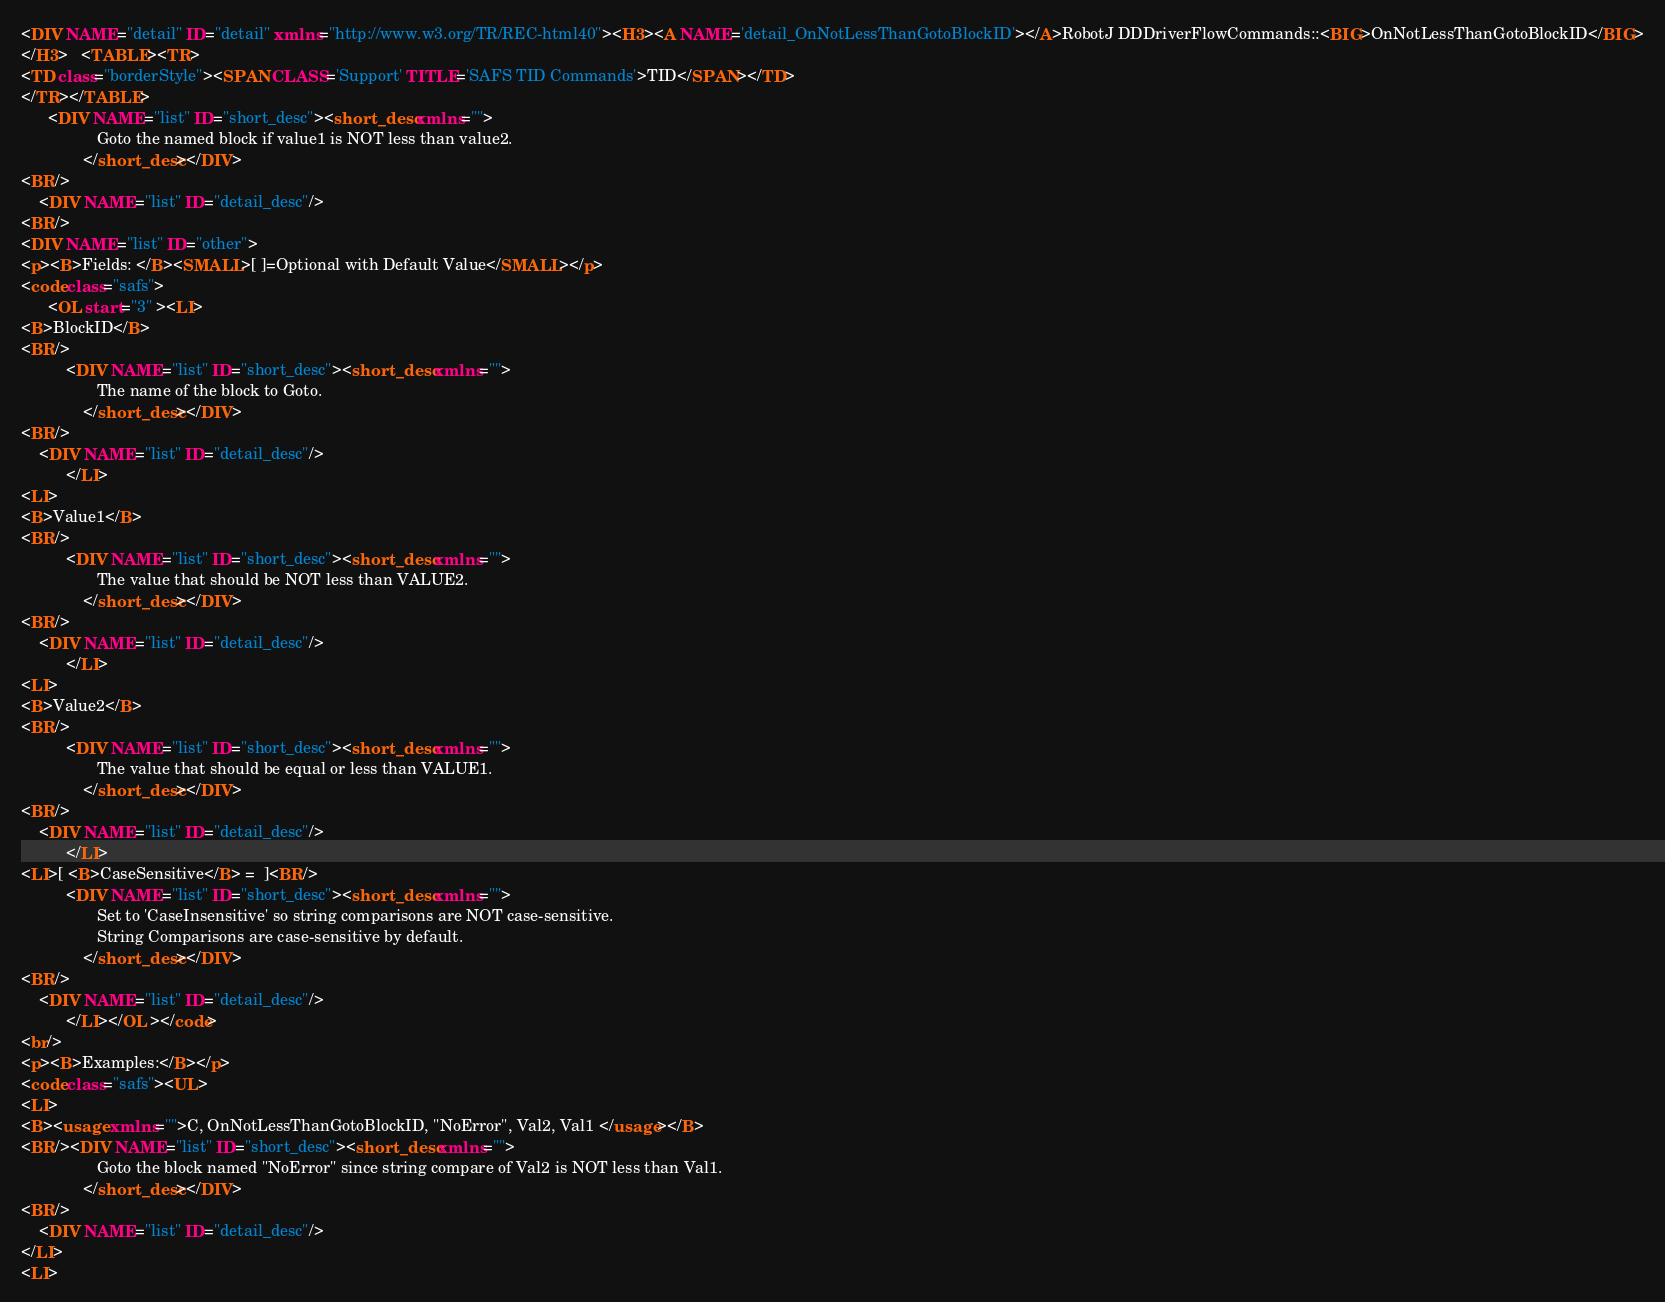<code> <loc_0><loc_0><loc_500><loc_500><_HTML_><DIV NAME="detail" ID="detail" xmlns="http://www.w3.org/TR/REC-html40"><H3><A NAME='detail_OnNotLessThanGotoBlockID'></A>RobotJ DDDriverFlowCommands::<BIG>OnNotLessThanGotoBlockID</BIG>
</H3>   <TABLE><TR>
<TD class="borderStyle"><SPAN CLASS='Support' TITLE='SAFS TID Commands'>TID</SPAN></TD>
</TR></TABLE>
	  <DIV NAME="list" ID="short_desc"><short_desc xmlns=""> 
                 Goto the named block if value1 is NOT less than value2.
              </short_desc></DIV>
<BR/>
	<DIV NAME="list" ID="detail_desc"/>
<BR/>
<DIV NAME="list" ID="other">
<p><B>Fields: </B><SMALL>[ ]=Optional with Default Value</SMALL></p>
<code class="safs">
	  <OL start="3" ><LI>
<B>BlockID</B>
<BR/>
		  <DIV NAME="list" ID="short_desc"><short_desc xmlns=""> 
                 The name of the block to Goto.
              </short_desc></DIV>
<BR/>
	<DIV NAME="list" ID="detail_desc"/>
		  </LI>
<LI>
<B>Value1</B>
<BR/>
		  <DIV NAME="list" ID="short_desc"><short_desc xmlns=""> 
                 The value that should be NOT less than VALUE2.
              </short_desc></DIV>
<BR/>
	<DIV NAME="list" ID="detail_desc"/>
		  </LI>
<LI>
<B>Value2</B>
<BR/>
		  <DIV NAME="list" ID="short_desc"><short_desc xmlns=""> 
                 The value that should be equal or less than VALUE1.
              </short_desc></DIV>
<BR/>
	<DIV NAME="list" ID="detail_desc"/>
		  </LI>
<LI>[ <B>CaseSensitive</B> =  ]<BR/>
		  <DIV NAME="list" ID="short_desc"><short_desc xmlns=""> 
                 Set to 'CaseInsensitive' so string comparisons are NOT case-sensitive.
                 String Comparisons are case-sensitive by default.
              </short_desc></DIV>
<BR/>
	<DIV NAME="list" ID="detail_desc"/>
		  </LI></OL ></code>
<br/>
<p><B>Examples:</B></p>
<code class="safs"><UL>
<LI>
<B><usage xmlns="">C, OnNotLessThanGotoBlockID, "NoError", Val2, Val1 </usage></B>
<BR/><DIV NAME="list" ID="short_desc"><short_desc xmlns=""> 
                 Goto the block named "NoError" since string compare of Val2 is NOT less than Val1.
              </short_desc></DIV>
<BR/>
	<DIV NAME="list" ID="detail_desc"/>
</LI>
<LI></code> 